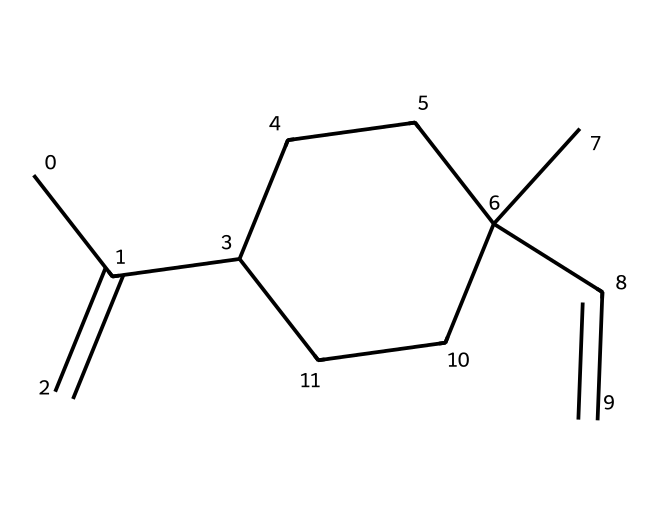What is the molecular formula of limonene? By counting the number of carbon (C) and hydrogen (H) atoms in the provided SMILES representation, we see there are 10 carbon atoms and 16 hydrogen atoms, thus the molecular formula is C10H16.
Answer: C10H16 How many double bonds are present in limonene? Inspecting the SMILES structure shows that there are two occurrences of the '=' sign indicating double bonds. Each '=' corresponds to a double bond, resulting in a total of 2 double bonds in limonene.
Answer: 2 What type of isomerism does limonene exhibit? Limonene, with its specific arrangement of atoms and the presence of double bonds in the carbon chain, is known to exhibit geometric isomerism (cis-trans isomerism) because the restricted rotation around the double bonds allows for different spatial configurations.
Answer: geometric isomerism Which specific geometric isomers can limonene have? Given that limonene has two double bonds, it can exist as two geometric isomers: (R)-limonene and (S)-limonene (also known as citral and limonene). The isomers differ based on the orientation of the substituents around the double bonds.
Answer: (R)-limonene and (S)-limonene How does the double bond affect the properties of limonene? The presence of double bonds in limonene introduces rigidity and affects the molecular shape, which influences its reactivity and interactions with other substances. Additionally, the geometry around double bonds can affect physical properties like boiling point and solubility as well as its scent.
Answer: reactivity and molecular shape What is the significance of the cis/trans relationships in limonene? The cis/trans relationships in limonene determine the spatial arrangement of its atoms, which heavily influences its aroma, functionality in products, and its ability to bind with enzymes or receptors in biological systems.
Answer: aroma and functionality 